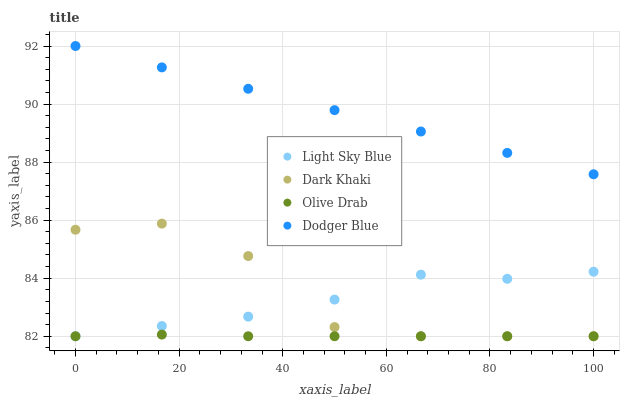Does Olive Drab have the minimum area under the curve?
Answer yes or no. Yes. Does Dodger Blue have the maximum area under the curve?
Answer yes or no. Yes. Does Light Sky Blue have the minimum area under the curve?
Answer yes or no. No. Does Light Sky Blue have the maximum area under the curve?
Answer yes or no. No. Is Dodger Blue the smoothest?
Answer yes or no. Yes. Is Dark Khaki the roughest?
Answer yes or no. Yes. Is Light Sky Blue the smoothest?
Answer yes or no. No. Is Light Sky Blue the roughest?
Answer yes or no. No. Does Dark Khaki have the lowest value?
Answer yes or no. Yes. Does Dodger Blue have the lowest value?
Answer yes or no. No. Does Dodger Blue have the highest value?
Answer yes or no. Yes. Does Light Sky Blue have the highest value?
Answer yes or no. No. Is Olive Drab less than Dodger Blue?
Answer yes or no. Yes. Is Dodger Blue greater than Dark Khaki?
Answer yes or no. Yes. Does Light Sky Blue intersect Olive Drab?
Answer yes or no. Yes. Is Light Sky Blue less than Olive Drab?
Answer yes or no. No. Is Light Sky Blue greater than Olive Drab?
Answer yes or no. No. Does Olive Drab intersect Dodger Blue?
Answer yes or no. No. 